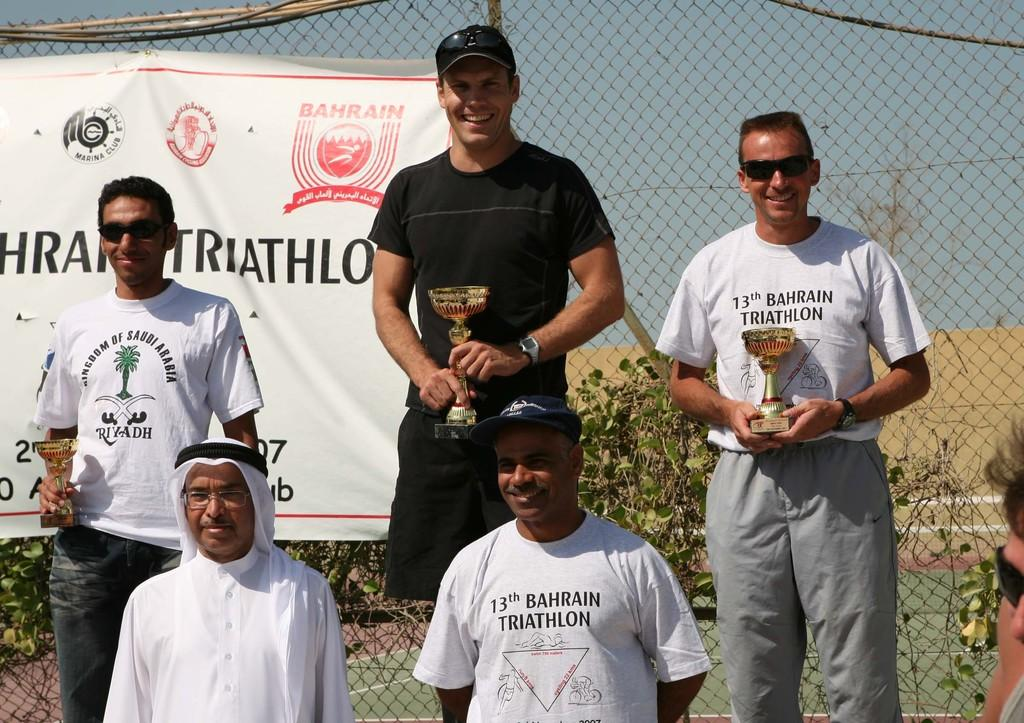<image>
Create a compact narrative representing the image presented. A group of men are on a podium holding awards they won for a triathlon. 